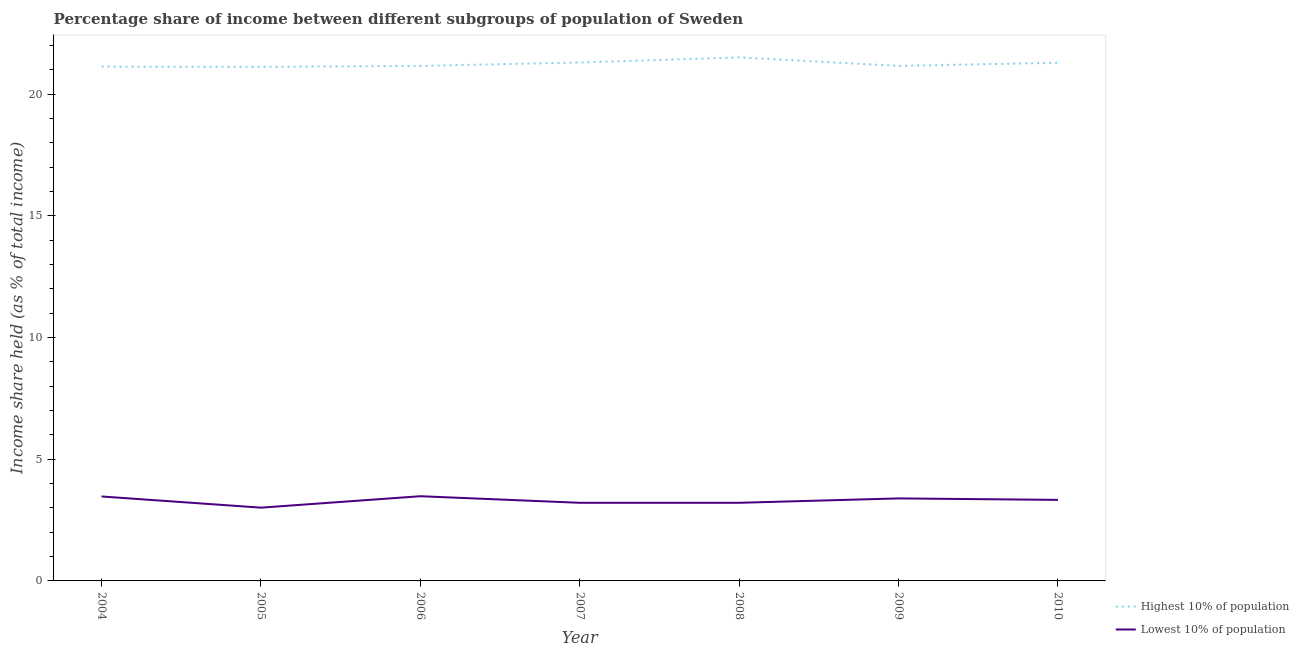What is the income share held by highest 10% of the population in 2009?
Make the answer very short. 21.16. Across all years, what is the maximum income share held by lowest 10% of the population?
Make the answer very short. 3.48. Across all years, what is the minimum income share held by lowest 10% of the population?
Offer a very short reply. 3.01. In which year was the income share held by highest 10% of the population maximum?
Your answer should be very brief. 2008. In which year was the income share held by highest 10% of the population minimum?
Make the answer very short. 2005. What is the total income share held by highest 10% of the population in the graph?
Give a very brief answer. 148.67. What is the difference between the income share held by lowest 10% of the population in 2005 and that in 2008?
Give a very brief answer. -0.2. What is the difference between the income share held by lowest 10% of the population in 2005 and the income share held by highest 10% of the population in 2008?
Make the answer very short. -18.5. What is the average income share held by highest 10% of the population per year?
Your answer should be very brief. 21.24. In the year 2010, what is the difference between the income share held by highest 10% of the population and income share held by lowest 10% of the population?
Offer a very short reply. 17.96. What is the ratio of the income share held by lowest 10% of the population in 2005 to that in 2010?
Offer a very short reply. 0.9. Is the income share held by lowest 10% of the population in 2004 less than that in 2005?
Keep it short and to the point. No. Is the difference between the income share held by lowest 10% of the population in 2005 and 2009 greater than the difference between the income share held by highest 10% of the population in 2005 and 2009?
Keep it short and to the point. No. What is the difference between the highest and the second highest income share held by highest 10% of the population?
Ensure brevity in your answer.  0.21. What is the difference between the highest and the lowest income share held by highest 10% of the population?
Give a very brief answer. 0.39. In how many years, is the income share held by lowest 10% of the population greater than the average income share held by lowest 10% of the population taken over all years?
Your answer should be very brief. 4. Is the sum of the income share held by lowest 10% of the population in 2005 and 2010 greater than the maximum income share held by highest 10% of the population across all years?
Give a very brief answer. No. Does the income share held by lowest 10% of the population monotonically increase over the years?
Your answer should be very brief. No. Is the income share held by highest 10% of the population strictly greater than the income share held by lowest 10% of the population over the years?
Provide a short and direct response. Yes. Is the income share held by lowest 10% of the population strictly less than the income share held by highest 10% of the population over the years?
Offer a terse response. Yes. Are the values on the major ticks of Y-axis written in scientific E-notation?
Your response must be concise. No. Does the graph contain grids?
Give a very brief answer. No. Where does the legend appear in the graph?
Ensure brevity in your answer.  Bottom right. How many legend labels are there?
Your response must be concise. 2. How are the legend labels stacked?
Give a very brief answer. Vertical. What is the title of the graph?
Keep it short and to the point. Percentage share of income between different subgroups of population of Sweden. Does "Non-resident workers" appear as one of the legend labels in the graph?
Provide a succinct answer. No. What is the label or title of the X-axis?
Your answer should be compact. Year. What is the label or title of the Y-axis?
Keep it short and to the point. Income share held (as % of total income). What is the Income share held (as % of total income) of Highest 10% of population in 2004?
Your answer should be very brief. 21.13. What is the Income share held (as % of total income) in Lowest 10% of population in 2004?
Give a very brief answer. 3.47. What is the Income share held (as % of total income) of Highest 10% of population in 2005?
Ensure brevity in your answer.  21.12. What is the Income share held (as % of total income) in Lowest 10% of population in 2005?
Ensure brevity in your answer.  3.01. What is the Income share held (as % of total income) of Highest 10% of population in 2006?
Offer a terse response. 21.16. What is the Income share held (as % of total income) of Lowest 10% of population in 2006?
Offer a terse response. 3.48. What is the Income share held (as % of total income) of Highest 10% of population in 2007?
Give a very brief answer. 21.3. What is the Income share held (as % of total income) in Lowest 10% of population in 2007?
Offer a very short reply. 3.21. What is the Income share held (as % of total income) of Highest 10% of population in 2008?
Your response must be concise. 21.51. What is the Income share held (as % of total income) in Lowest 10% of population in 2008?
Provide a succinct answer. 3.21. What is the Income share held (as % of total income) in Highest 10% of population in 2009?
Ensure brevity in your answer.  21.16. What is the Income share held (as % of total income) of Lowest 10% of population in 2009?
Your response must be concise. 3.39. What is the Income share held (as % of total income) of Highest 10% of population in 2010?
Provide a short and direct response. 21.29. What is the Income share held (as % of total income) in Lowest 10% of population in 2010?
Give a very brief answer. 3.33. Across all years, what is the maximum Income share held (as % of total income) of Highest 10% of population?
Give a very brief answer. 21.51. Across all years, what is the maximum Income share held (as % of total income) in Lowest 10% of population?
Your answer should be very brief. 3.48. Across all years, what is the minimum Income share held (as % of total income) in Highest 10% of population?
Offer a very short reply. 21.12. Across all years, what is the minimum Income share held (as % of total income) of Lowest 10% of population?
Provide a succinct answer. 3.01. What is the total Income share held (as % of total income) in Highest 10% of population in the graph?
Provide a short and direct response. 148.67. What is the total Income share held (as % of total income) of Lowest 10% of population in the graph?
Offer a terse response. 23.1. What is the difference between the Income share held (as % of total income) in Highest 10% of population in 2004 and that in 2005?
Provide a short and direct response. 0.01. What is the difference between the Income share held (as % of total income) in Lowest 10% of population in 2004 and that in 2005?
Make the answer very short. 0.46. What is the difference between the Income share held (as % of total income) of Highest 10% of population in 2004 and that in 2006?
Provide a succinct answer. -0.03. What is the difference between the Income share held (as % of total income) in Lowest 10% of population in 2004 and that in 2006?
Offer a terse response. -0.01. What is the difference between the Income share held (as % of total income) of Highest 10% of population in 2004 and that in 2007?
Your answer should be compact. -0.17. What is the difference between the Income share held (as % of total income) in Lowest 10% of population in 2004 and that in 2007?
Your response must be concise. 0.26. What is the difference between the Income share held (as % of total income) in Highest 10% of population in 2004 and that in 2008?
Your response must be concise. -0.38. What is the difference between the Income share held (as % of total income) of Lowest 10% of population in 2004 and that in 2008?
Keep it short and to the point. 0.26. What is the difference between the Income share held (as % of total income) of Highest 10% of population in 2004 and that in 2009?
Offer a very short reply. -0.03. What is the difference between the Income share held (as % of total income) of Highest 10% of population in 2004 and that in 2010?
Your answer should be compact. -0.16. What is the difference between the Income share held (as % of total income) in Lowest 10% of population in 2004 and that in 2010?
Offer a terse response. 0.14. What is the difference between the Income share held (as % of total income) in Highest 10% of population in 2005 and that in 2006?
Your answer should be very brief. -0.04. What is the difference between the Income share held (as % of total income) in Lowest 10% of population in 2005 and that in 2006?
Ensure brevity in your answer.  -0.47. What is the difference between the Income share held (as % of total income) of Highest 10% of population in 2005 and that in 2007?
Your answer should be very brief. -0.18. What is the difference between the Income share held (as % of total income) in Highest 10% of population in 2005 and that in 2008?
Offer a very short reply. -0.39. What is the difference between the Income share held (as % of total income) of Lowest 10% of population in 2005 and that in 2008?
Your answer should be very brief. -0.2. What is the difference between the Income share held (as % of total income) in Highest 10% of population in 2005 and that in 2009?
Make the answer very short. -0.04. What is the difference between the Income share held (as % of total income) in Lowest 10% of population in 2005 and that in 2009?
Provide a succinct answer. -0.38. What is the difference between the Income share held (as % of total income) of Highest 10% of population in 2005 and that in 2010?
Keep it short and to the point. -0.17. What is the difference between the Income share held (as % of total income) in Lowest 10% of population in 2005 and that in 2010?
Ensure brevity in your answer.  -0.32. What is the difference between the Income share held (as % of total income) of Highest 10% of population in 2006 and that in 2007?
Provide a short and direct response. -0.14. What is the difference between the Income share held (as % of total income) in Lowest 10% of population in 2006 and that in 2007?
Ensure brevity in your answer.  0.27. What is the difference between the Income share held (as % of total income) in Highest 10% of population in 2006 and that in 2008?
Provide a short and direct response. -0.35. What is the difference between the Income share held (as % of total income) in Lowest 10% of population in 2006 and that in 2008?
Provide a short and direct response. 0.27. What is the difference between the Income share held (as % of total income) of Highest 10% of population in 2006 and that in 2009?
Your answer should be compact. 0. What is the difference between the Income share held (as % of total income) of Lowest 10% of population in 2006 and that in 2009?
Provide a succinct answer. 0.09. What is the difference between the Income share held (as % of total income) in Highest 10% of population in 2006 and that in 2010?
Keep it short and to the point. -0.13. What is the difference between the Income share held (as % of total income) of Highest 10% of population in 2007 and that in 2008?
Offer a terse response. -0.21. What is the difference between the Income share held (as % of total income) of Highest 10% of population in 2007 and that in 2009?
Your answer should be very brief. 0.14. What is the difference between the Income share held (as % of total income) of Lowest 10% of population in 2007 and that in 2009?
Keep it short and to the point. -0.18. What is the difference between the Income share held (as % of total income) in Highest 10% of population in 2007 and that in 2010?
Your response must be concise. 0.01. What is the difference between the Income share held (as % of total income) in Lowest 10% of population in 2007 and that in 2010?
Provide a succinct answer. -0.12. What is the difference between the Income share held (as % of total income) in Lowest 10% of population in 2008 and that in 2009?
Your answer should be compact. -0.18. What is the difference between the Income share held (as % of total income) in Highest 10% of population in 2008 and that in 2010?
Provide a short and direct response. 0.22. What is the difference between the Income share held (as % of total income) of Lowest 10% of population in 2008 and that in 2010?
Ensure brevity in your answer.  -0.12. What is the difference between the Income share held (as % of total income) of Highest 10% of population in 2009 and that in 2010?
Your answer should be very brief. -0.13. What is the difference between the Income share held (as % of total income) of Lowest 10% of population in 2009 and that in 2010?
Provide a succinct answer. 0.06. What is the difference between the Income share held (as % of total income) of Highest 10% of population in 2004 and the Income share held (as % of total income) of Lowest 10% of population in 2005?
Provide a short and direct response. 18.12. What is the difference between the Income share held (as % of total income) in Highest 10% of population in 2004 and the Income share held (as % of total income) in Lowest 10% of population in 2006?
Provide a succinct answer. 17.65. What is the difference between the Income share held (as % of total income) of Highest 10% of population in 2004 and the Income share held (as % of total income) of Lowest 10% of population in 2007?
Offer a very short reply. 17.92. What is the difference between the Income share held (as % of total income) of Highest 10% of population in 2004 and the Income share held (as % of total income) of Lowest 10% of population in 2008?
Offer a terse response. 17.92. What is the difference between the Income share held (as % of total income) in Highest 10% of population in 2004 and the Income share held (as % of total income) in Lowest 10% of population in 2009?
Offer a terse response. 17.74. What is the difference between the Income share held (as % of total income) of Highest 10% of population in 2004 and the Income share held (as % of total income) of Lowest 10% of population in 2010?
Offer a terse response. 17.8. What is the difference between the Income share held (as % of total income) in Highest 10% of population in 2005 and the Income share held (as % of total income) in Lowest 10% of population in 2006?
Provide a short and direct response. 17.64. What is the difference between the Income share held (as % of total income) of Highest 10% of population in 2005 and the Income share held (as % of total income) of Lowest 10% of population in 2007?
Keep it short and to the point. 17.91. What is the difference between the Income share held (as % of total income) of Highest 10% of population in 2005 and the Income share held (as % of total income) of Lowest 10% of population in 2008?
Your response must be concise. 17.91. What is the difference between the Income share held (as % of total income) in Highest 10% of population in 2005 and the Income share held (as % of total income) in Lowest 10% of population in 2009?
Ensure brevity in your answer.  17.73. What is the difference between the Income share held (as % of total income) of Highest 10% of population in 2005 and the Income share held (as % of total income) of Lowest 10% of population in 2010?
Keep it short and to the point. 17.79. What is the difference between the Income share held (as % of total income) of Highest 10% of population in 2006 and the Income share held (as % of total income) of Lowest 10% of population in 2007?
Provide a short and direct response. 17.95. What is the difference between the Income share held (as % of total income) of Highest 10% of population in 2006 and the Income share held (as % of total income) of Lowest 10% of population in 2008?
Ensure brevity in your answer.  17.95. What is the difference between the Income share held (as % of total income) in Highest 10% of population in 2006 and the Income share held (as % of total income) in Lowest 10% of population in 2009?
Give a very brief answer. 17.77. What is the difference between the Income share held (as % of total income) in Highest 10% of population in 2006 and the Income share held (as % of total income) in Lowest 10% of population in 2010?
Make the answer very short. 17.83. What is the difference between the Income share held (as % of total income) in Highest 10% of population in 2007 and the Income share held (as % of total income) in Lowest 10% of population in 2008?
Ensure brevity in your answer.  18.09. What is the difference between the Income share held (as % of total income) in Highest 10% of population in 2007 and the Income share held (as % of total income) in Lowest 10% of population in 2009?
Your answer should be very brief. 17.91. What is the difference between the Income share held (as % of total income) of Highest 10% of population in 2007 and the Income share held (as % of total income) of Lowest 10% of population in 2010?
Make the answer very short. 17.97. What is the difference between the Income share held (as % of total income) of Highest 10% of population in 2008 and the Income share held (as % of total income) of Lowest 10% of population in 2009?
Your answer should be compact. 18.12. What is the difference between the Income share held (as % of total income) of Highest 10% of population in 2008 and the Income share held (as % of total income) of Lowest 10% of population in 2010?
Provide a short and direct response. 18.18. What is the difference between the Income share held (as % of total income) of Highest 10% of population in 2009 and the Income share held (as % of total income) of Lowest 10% of population in 2010?
Give a very brief answer. 17.83. What is the average Income share held (as % of total income) in Highest 10% of population per year?
Give a very brief answer. 21.24. What is the average Income share held (as % of total income) in Lowest 10% of population per year?
Your answer should be very brief. 3.3. In the year 2004, what is the difference between the Income share held (as % of total income) of Highest 10% of population and Income share held (as % of total income) of Lowest 10% of population?
Offer a very short reply. 17.66. In the year 2005, what is the difference between the Income share held (as % of total income) in Highest 10% of population and Income share held (as % of total income) in Lowest 10% of population?
Offer a very short reply. 18.11. In the year 2006, what is the difference between the Income share held (as % of total income) in Highest 10% of population and Income share held (as % of total income) in Lowest 10% of population?
Offer a very short reply. 17.68. In the year 2007, what is the difference between the Income share held (as % of total income) of Highest 10% of population and Income share held (as % of total income) of Lowest 10% of population?
Offer a very short reply. 18.09. In the year 2009, what is the difference between the Income share held (as % of total income) in Highest 10% of population and Income share held (as % of total income) in Lowest 10% of population?
Provide a succinct answer. 17.77. In the year 2010, what is the difference between the Income share held (as % of total income) in Highest 10% of population and Income share held (as % of total income) in Lowest 10% of population?
Your answer should be compact. 17.96. What is the ratio of the Income share held (as % of total income) in Lowest 10% of population in 2004 to that in 2005?
Offer a terse response. 1.15. What is the ratio of the Income share held (as % of total income) in Highest 10% of population in 2004 to that in 2006?
Offer a terse response. 1. What is the ratio of the Income share held (as % of total income) of Lowest 10% of population in 2004 to that in 2006?
Keep it short and to the point. 1. What is the ratio of the Income share held (as % of total income) of Highest 10% of population in 2004 to that in 2007?
Give a very brief answer. 0.99. What is the ratio of the Income share held (as % of total income) in Lowest 10% of population in 2004 to that in 2007?
Your answer should be compact. 1.08. What is the ratio of the Income share held (as % of total income) in Highest 10% of population in 2004 to that in 2008?
Your answer should be compact. 0.98. What is the ratio of the Income share held (as % of total income) in Lowest 10% of population in 2004 to that in 2008?
Your response must be concise. 1.08. What is the ratio of the Income share held (as % of total income) of Lowest 10% of population in 2004 to that in 2009?
Provide a succinct answer. 1.02. What is the ratio of the Income share held (as % of total income) in Highest 10% of population in 2004 to that in 2010?
Your answer should be very brief. 0.99. What is the ratio of the Income share held (as % of total income) of Lowest 10% of population in 2004 to that in 2010?
Make the answer very short. 1.04. What is the ratio of the Income share held (as % of total income) of Highest 10% of population in 2005 to that in 2006?
Provide a short and direct response. 1. What is the ratio of the Income share held (as % of total income) of Lowest 10% of population in 2005 to that in 2006?
Keep it short and to the point. 0.86. What is the ratio of the Income share held (as % of total income) of Highest 10% of population in 2005 to that in 2007?
Your response must be concise. 0.99. What is the ratio of the Income share held (as % of total income) in Lowest 10% of population in 2005 to that in 2007?
Your response must be concise. 0.94. What is the ratio of the Income share held (as % of total income) in Highest 10% of population in 2005 to that in 2008?
Your response must be concise. 0.98. What is the ratio of the Income share held (as % of total income) in Lowest 10% of population in 2005 to that in 2008?
Offer a terse response. 0.94. What is the ratio of the Income share held (as % of total income) of Highest 10% of population in 2005 to that in 2009?
Your response must be concise. 1. What is the ratio of the Income share held (as % of total income) in Lowest 10% of population in 2005 to that in 2009?
Provide a short and direct response. 0.89. What is the ratio of the Income share held (as % of total income) in Lowest 10% of population in 2005 to that in 2010?
Ensure brevity in your answer.  0.9. What is the ratio of the Income share held (as % of total income) in Lowest 10% of population in 2006 to that in 2007?
Your response must be concise. 1.08. What is the ratio of the Income share held (as % of total income) in Highest 10% of population in 2006 to that in 2008?
Your response must be concise. 0.98. What is the ratio of the Income share held (as % of total income) of Lowest 10% of population in 2006 to that in 2008?
Ensure brevity in your answer.  1.08. What is the ratio of the Income share held (as % of total income) in Lowest 10% of population in 2006 to that in 2009?
Offer a terse response. 1.03. What is the ratio of the Income share held (as % of total income) in Highest 10% of population in 2006 to that in 2010?
Offer a very short reply. 0.99. What is the ratio of the Income share held (as % of total income) in Lowest 10% of population in 2006 to that in 2010?
Make the answer very short. 1.04. What is the ratio of the Income share held (as % of total income) of Highest 10% of population in 2007 to that in 2008?
Your response must be concise. 0.99. What is the ratio of the Income share held (as % of total income) in Lowest 10% of population in 2007 to that in 2008?
Your answer should be compact. 1. What is the ratio of the Income share held (as % of total income) in Highest 10% of population in 2007 to that in 2009?
Keep it short and to the point. 1.01. What is the ratio of the Income share held (as % of total income) of Lowest 10% of population in 2007 to that in 2009?
Keep it short and to the point. 0.95. What is the ratio of the Income share held (as % of total income) in Lowest 10% of population in 2007 to that in 2010?
Make the answer very short. 0.96. What is the ratio of the Income share held (as % of total income) in Highest 10% of population in 2008 to that in 2009?
Offer a terse response. 1.02. What is the ratio of the Income share held (as % of total income) of Lowest 10% of population in 2008 to that in 2009?
Make the answer very short. 0.95. What is the ratio of the Income share held (as % of total income) in Highest 10% of population in 2008 to that in 2010?
Provide a succinct answer. 1.01. What is the ratio of the Income share held (as % of total income) of Lowest 10% of population in 2008 to that in 2010?
Your response must be concise. 0.96. What is the ratio of the Income share held (as % of total income) in Lowest 10% of population in 2009 to that in 2010?
Provide a succinct answer. 1.02. What is the difference between the highest and the second highest Income share held (as % of total income) in Highest 10% of population?
Keep it short and to the point. 0.21. What is the difference between the highest and the second highest Income share held (as % of total income) in Lowest 10% of population?
Your answer should be compact. 0.01. What is the difference between the highest and the lowest Income share held (as % of total income) of Highest 10% of population?
Provide a succinct answer. 0.39. What is the difference between the highest and the lowest Income share held (as % of total income) in Lowest 10% of population?
Provide a short and direct response. 0.47. 